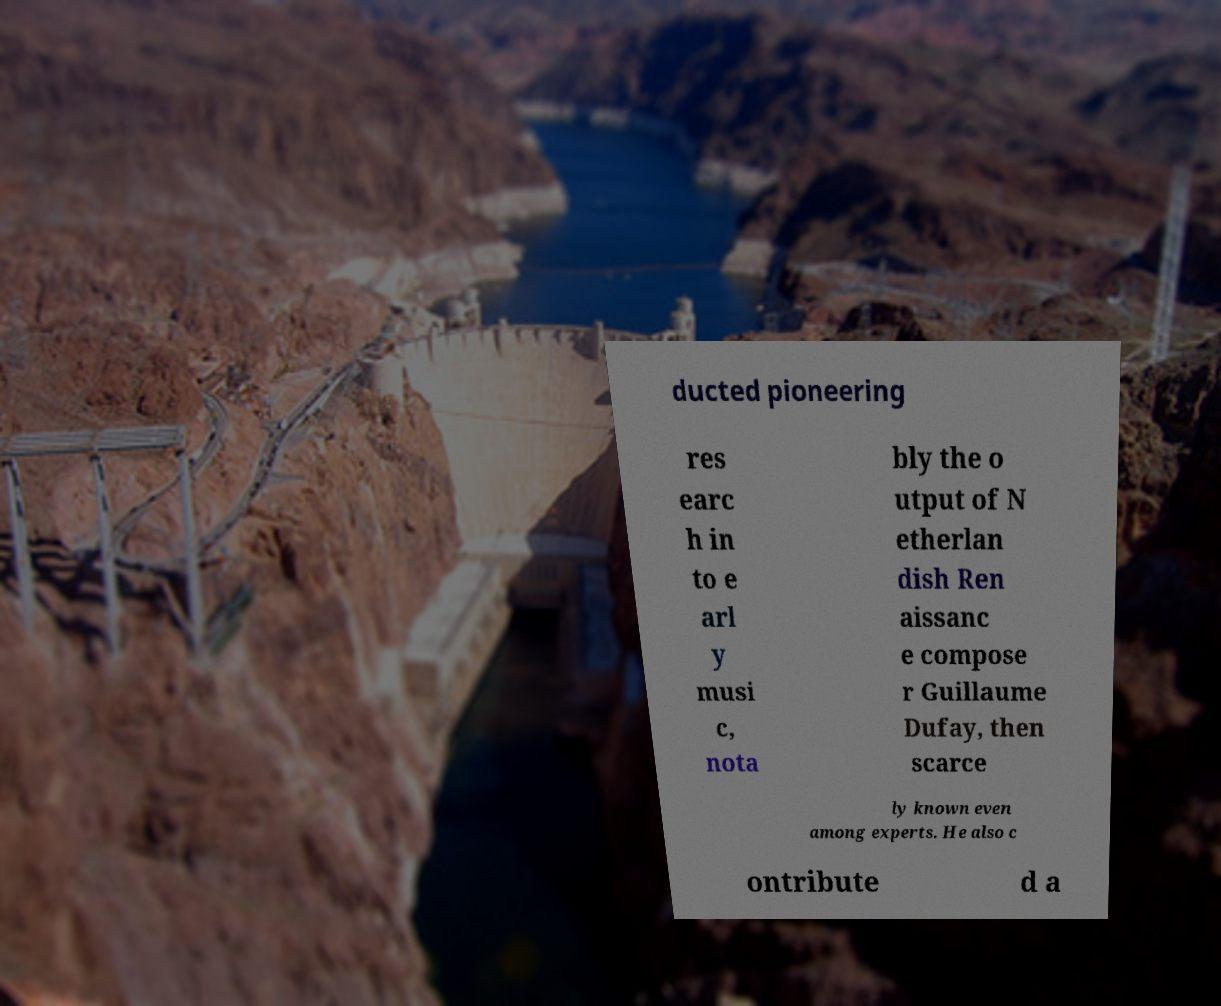Please read and relay the text visible in this image. What does it say? ducted pioneering res earc h in to e arl y musi c, nota bly the o utput of N etherlan dish Ren aissanc e compose r Guillaume Dufay, then scarce ly known even among experts. He also c ontribute d a 